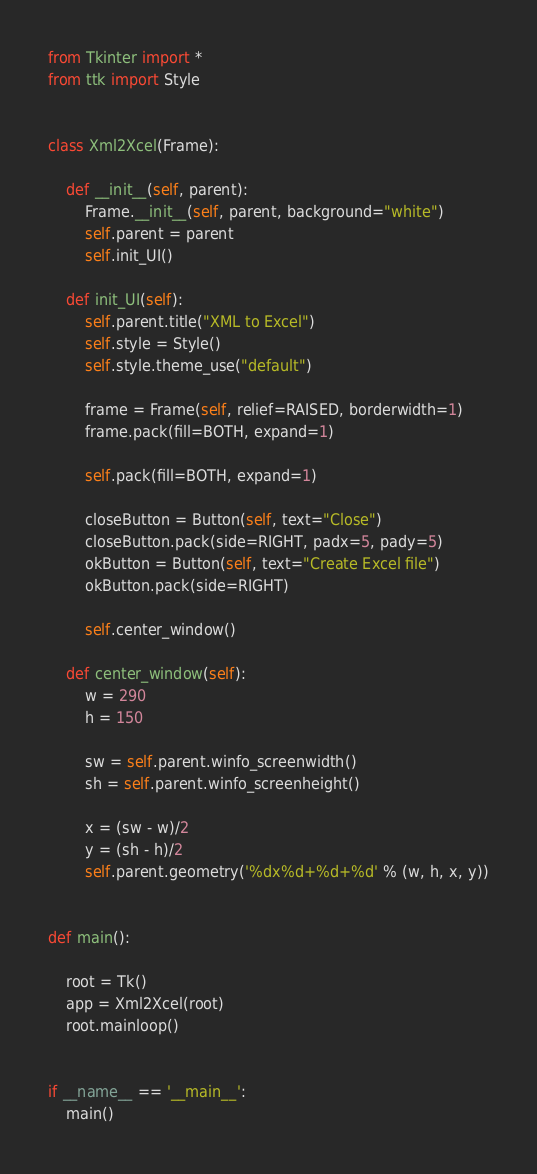<code> <loc_0><loc_0><loc_500><loc_500><_Python_>from Tkinter import *
from ttk import Style


class Xml2Xcel(Frame):
  
    def __init__(self, parent):
        Frame.__init__(self, parent, background="white")   
        self.parent = parent
        self.init_UI()
    
    def init_UI(self):
        self.parent.title("XML to Excel")
        self.style = Style()
        self.style.theme_use("default")

        frame = Frame(self, relief=RAISED, borderwidth=1)
        frame.pack(fill=BOTH, expand=1)

        self.pack(fill=BOTH, expand=1)

        closeButton = Button(self, text="Close")
        closeButton.pack(side=RIGHT, padx=5, pady=5)
        okButton = Button(self, text="Create Excel file")
        okButton.pack(side=RIGHT)

        self.center_window()
        
    def center_window(self):
        w = 290
        h = 150

        sw = self.parent.winfo_screenwidth()
        sh = self.parent.winfo_screenheight()
        
        x = (sw - w)/2
        y = (sh - h)/2
        self.parent.geometry('%dx%d+%d+%d' % (w, h, x, y))


def main():
  
    root = Tk()
    app = Xml2Xcel(root)
    root.mainloop()  


if __name__ == '__main__':
    main() </code> 